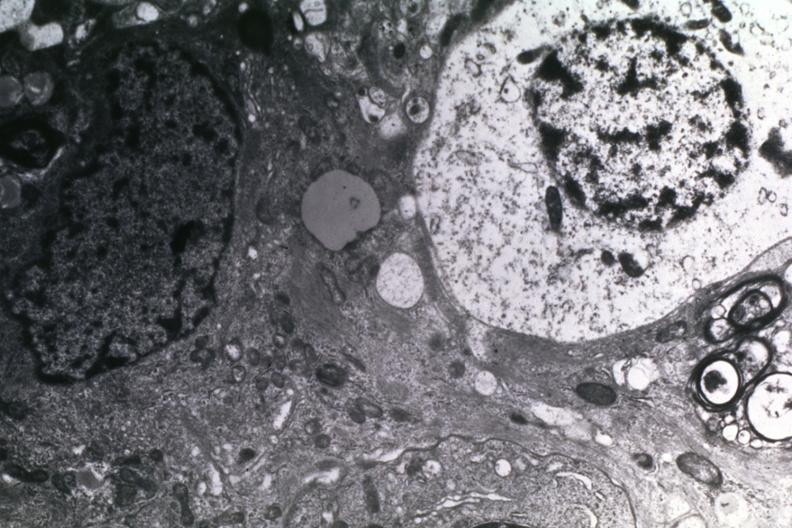what is present?
Answer the question using a single word or phrase. Glioblastoma multiforme 